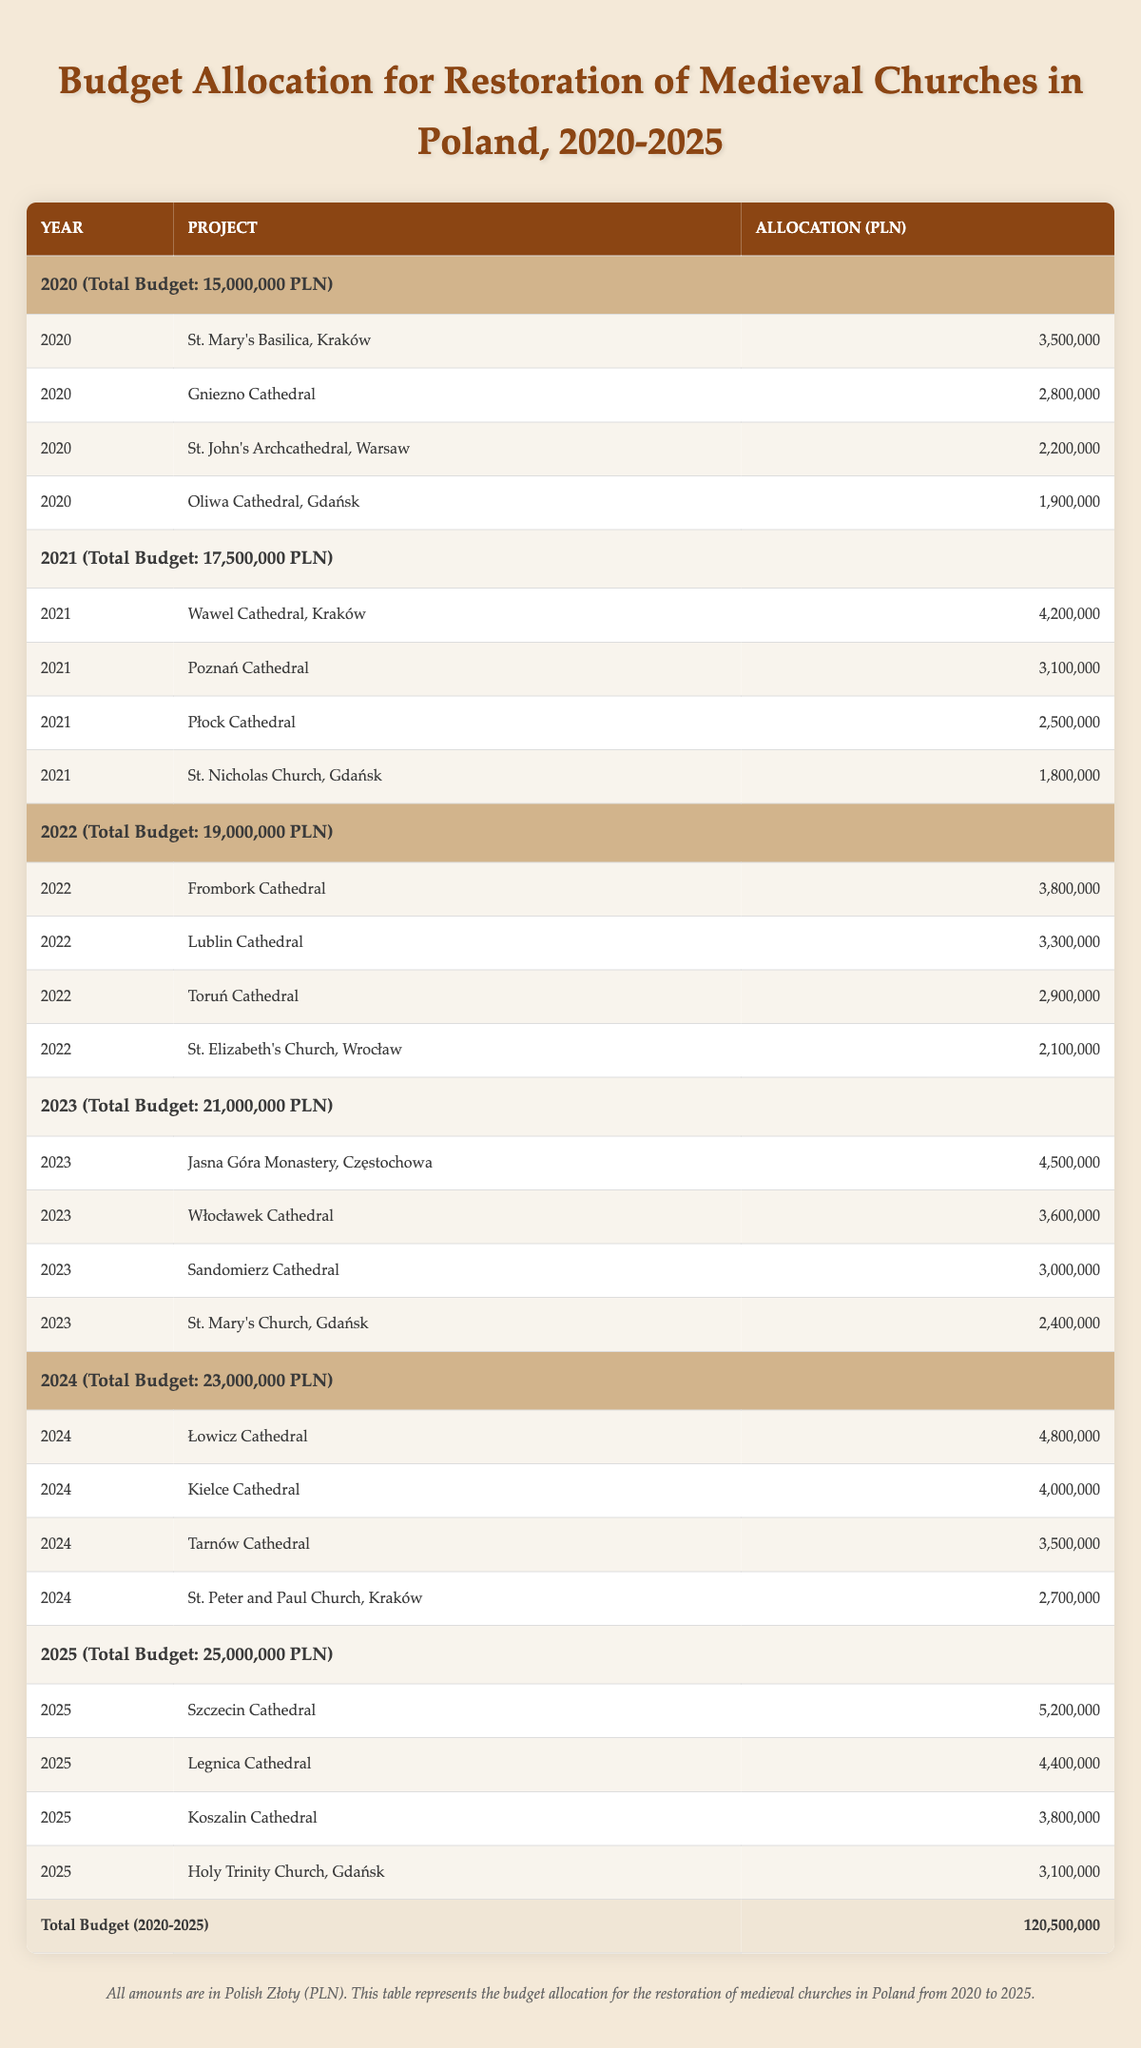What is the total budget allocated for the restoration of medieval churches in 2020? The table specifies that the total budget for 2020 is 15,000,000 PLN, as seen in the header row for that year.
Answer: 15,000,000 PLN Which project received the highest allocation in 2021? In 2021, the Wawel Cathedral in Kraków received the highest allocation of 4,200,000 PLN, as noted in the project list for that year.
Answer: Wawel Cathedral, Kraków What is the total allocation for the projects in 2023? The allocations for projects in 2023 are 4,500,000 + 3,600,000 + 3,000,000 + 2,400,000. Adding these gives a total of 13,500,000 PLN.
Answer: 13,500,000 PLN Did the total budget increase every year from 2020 to 2025? Yes, reviewing the total budget for each year shows an increase: 15,000,000 (2020), 17,500,000 (2021), 19,000,000 (2022), 21,000,000 (2023), 23,000,000 (2024), and 25,000,000 (2025). Each subsequent year has a higher total.
Answer: Yes What was the average allocation per project in 2022? In 2022, there are 4 projects with allocations: 3,800,000 + 3,300,000 + 2,900,000 + 2,100,000. The total is 12,100,000 PLN. Dividing by the 4 projects gives an average allocation of 3,025,000 PLN.
Answer: 3,025,000 PLN Which project had the lowest budget allocation in 2024? The project with the lowest allocation in 2024 was St. Peter and Paul Church, Kraków, which received 2,700,000 PLN, as listed in that year's project allocations.
Answer: St. Peter and Paul Church, Kraków What is the difference between the total budget for 2025 and that of 2021? The total budgets are 25,000,000 PLN for 2025 and 17,500,000 PLN for 2021. The difference is 25,000,000 - 17,500,000 = 7,500,000 PLN.
Answer: 7,500,000 PLN How much budget was allocated for the restoration of Gdańsk churches in 2025? The allocations for Gdańsk churches in 2025 are Holy Trinity Church (3,100,000 PLN). Therefore, the total allocation for Gdańsk churches in that year is 3,100,000 PLN.
Answer: 3,100,000 PLN Which year had the second highest total budget, and what was that budget? The year with the second highest total budget is 2024, with a budget of 23,000,000 PLN, as indicated in the table.
Answer: 2024, 23,000,000 PLN 